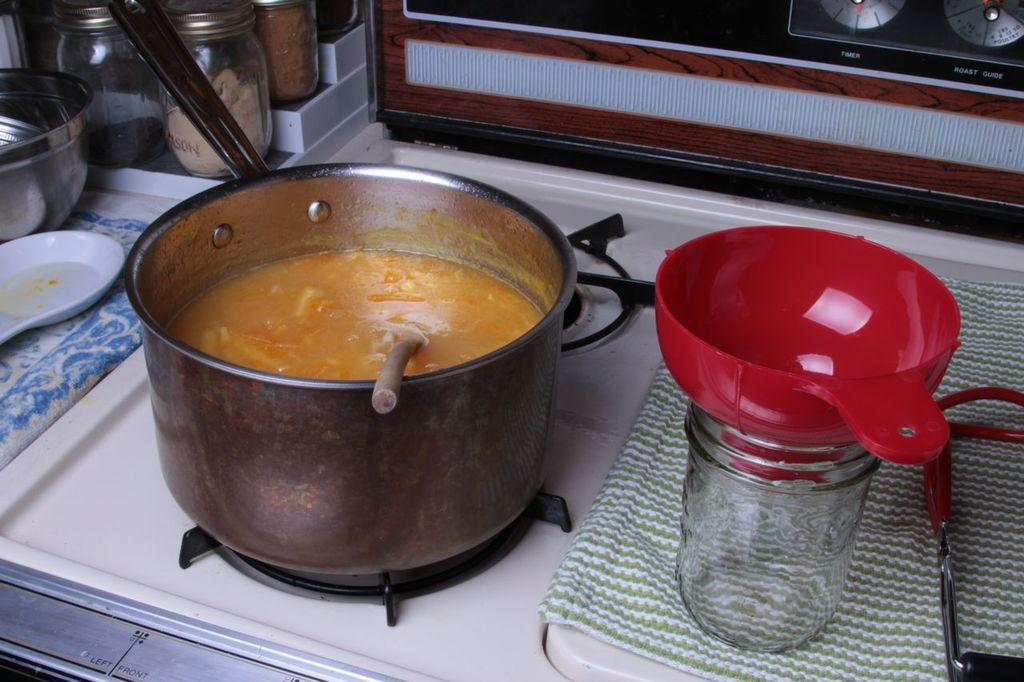What is on the stove in the image? There is food in a bowl on the stove. What type of containers can be seen in the image? There are jars and bowls in the image. What utensils are present in the image? There are spoons in the image. What type of items are related to clothing in the image? There are clothes in the image. What other objects can be seen in the image? There are other objects in the image. What type of stocking is being discussed in the meeting in the image? There is no meeting or stocking present in the image. What advice does the grandfather give about the food in the image? There is no grandfather present in the image, and therefore no advice can be given. 